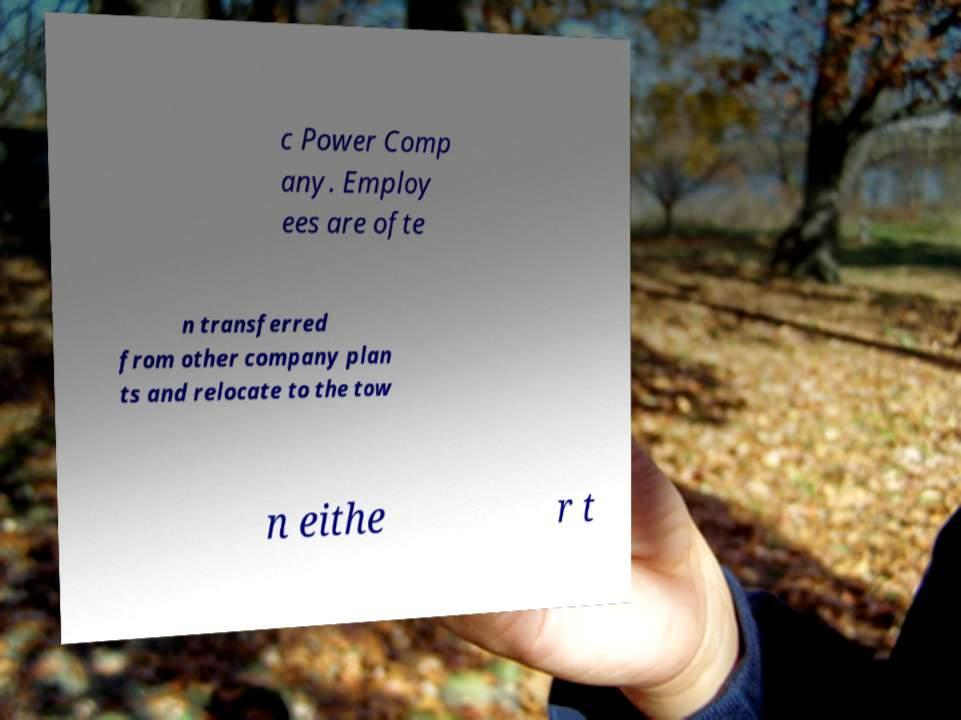What messages or text are displayed in this image? I need them in a readable, typed format. c Power Comp any. Employ ees are ofte n transferred from other company plan ts and relocate to the tow n eithe r t 